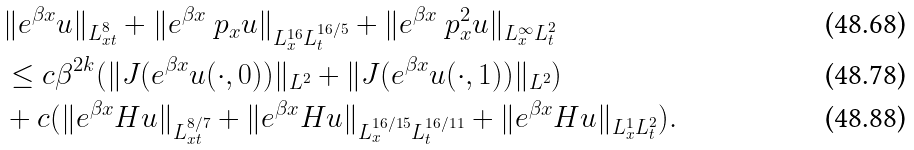Convert formula to latex. <formula><loc_0><loc_0><loc_500><loc_500>& \| e ^ { \beta x } u \| _ { L ^ { 8 } _ { x t } } + \| e ^ { \beta x } \ p _ { x } u \| _ { L ^ { 1 6 } _ { x } L ^ { 1 6 / 5 } _ { t } } + \| e ^ { \beta x } \ p _ { x } ^ { 2 } u \| _ { L ^ { \infty } _ { x } L ^ { 2 } _ { t } } \\ & \leq c \beta ^ { 2 k } ( \| J ( e ^ { \beta x } u ( \cdot , 0 ) ) \| _ { L ^ { 2 } } + \| J ( e ^ { \beta x } u ( \cdot , 1 ) ) \| _ { L ^ { 2 } } ) \\ & + c ( \| e ^ { \beta x } H u \| _ { L ^ { 8 / 7 } _ { x t } } + \| e ^ { \beta x } H u \| _ { L ^ { 1 6 / 1 5 } _ { x } L ^ { 1 6 / 1 1 } _ { t } } + \| e ^ { \beta x } H u \| _ { L ^ { 1 } _ { x } L ^ { 2 } _ { t } } ) .</formula> 